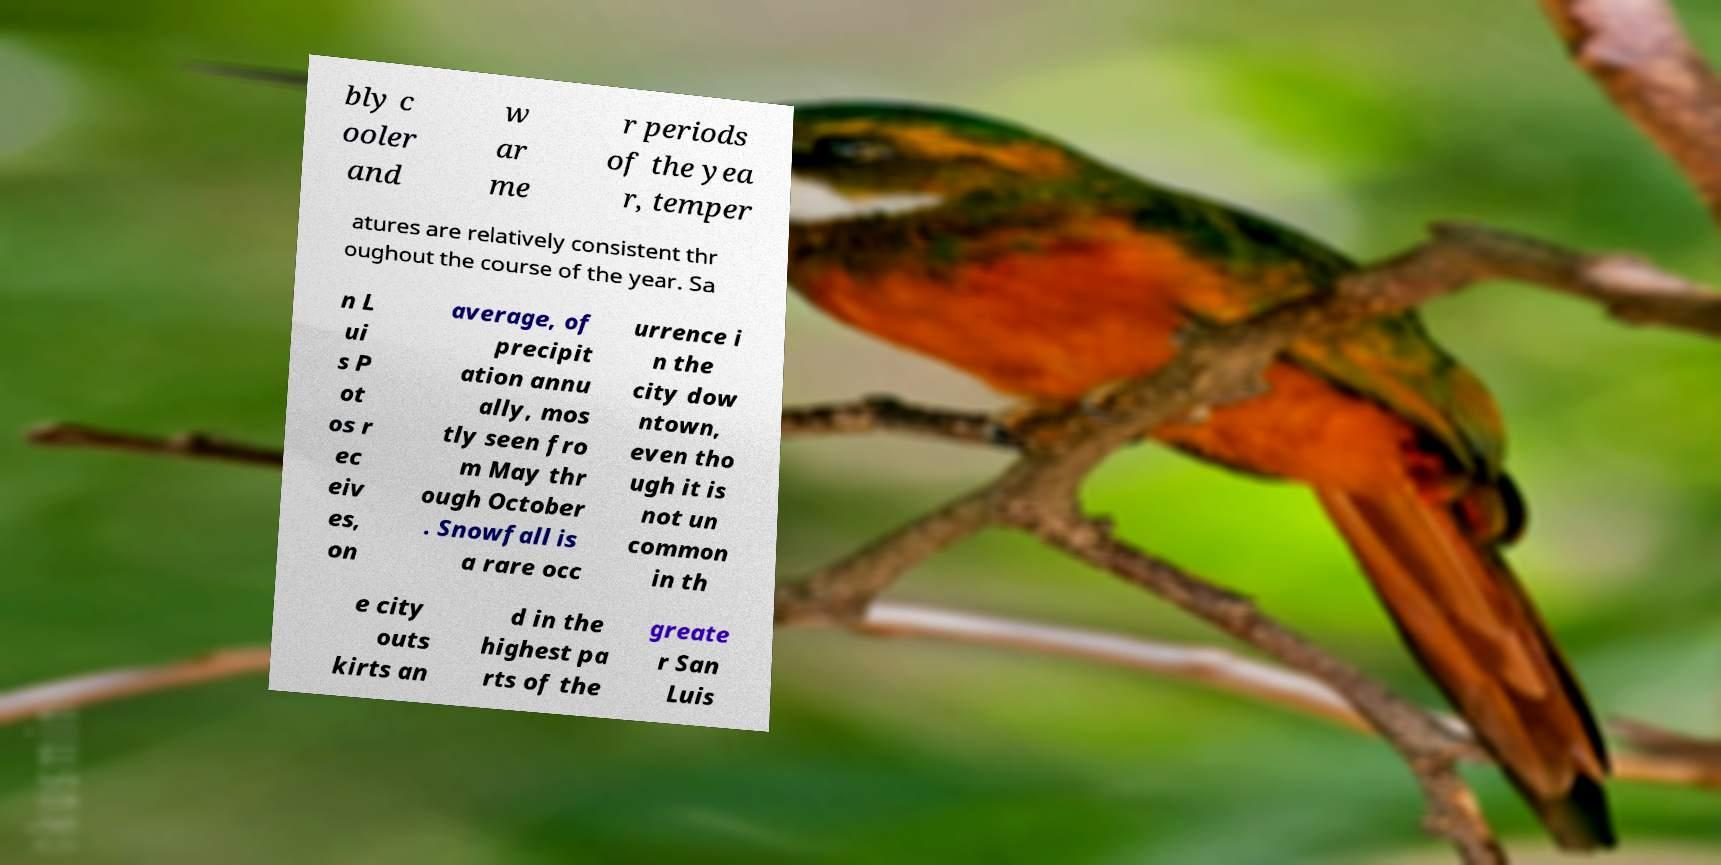Could you extract and type out the text from this image? bly c ooler and w ar me r periods of the yea r, temper atures are relatively consistent thr oughout the course of the year. Sa n L ui s P ot os r ec eiv es, on average, of precipit ation annu ally, mos tly seen fro m May thr ough October . Snowfall is a rare occ urrence i n the city dow ntown, even tho ugh it is not un common in th e city outs kirts an d in the highest pa rts of the greate r San Luis 